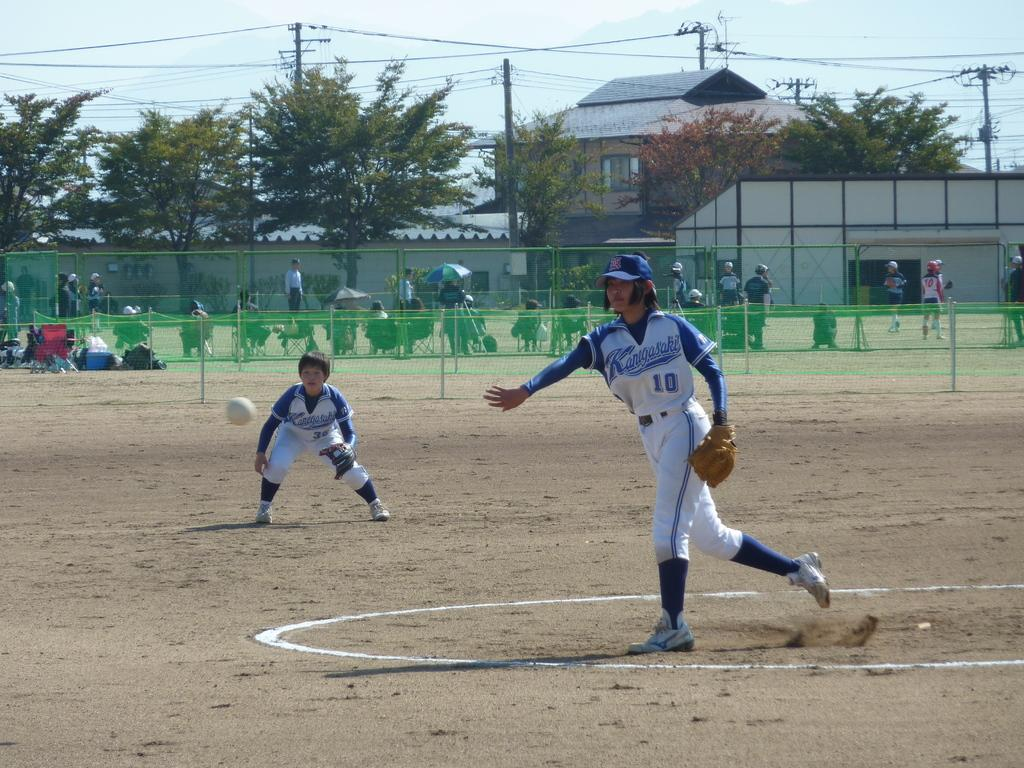<image>
Present a compact description of the photo's key features. Player number 10 throws the ball as a player to the right readies for a play. 